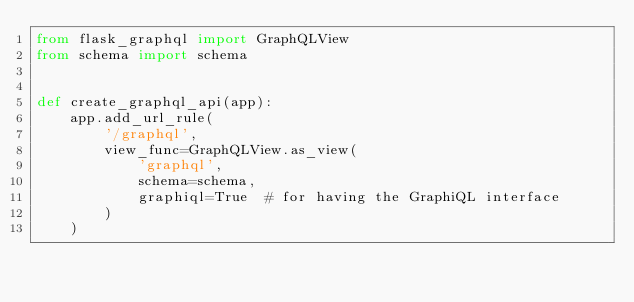<code> <loc_0><loc_0><loc_500><loc_500><_Python_>from flask_graphql import GraphQLView
from schema import schema


def create_graphql_api(app):
    app.add_url_rule(
        '/graphql',
        view_func=GraphQLView.as_view(
            'graphql',
            schema=schema,
            graphiql=True  # for having the GraphiQL interface
        )
    )</code> 